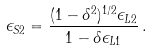<formula> <loc_0><loc_0><loc_500><loc_500>\epsilon _ { S 2 } = \frac { ( 1 - \delta ^ { 2 } ) ^ { 1 / 2 } \epsilon _ { L 2 } } { 1 - \delta \epsilon _ { L 1 } } \, .</formula> 